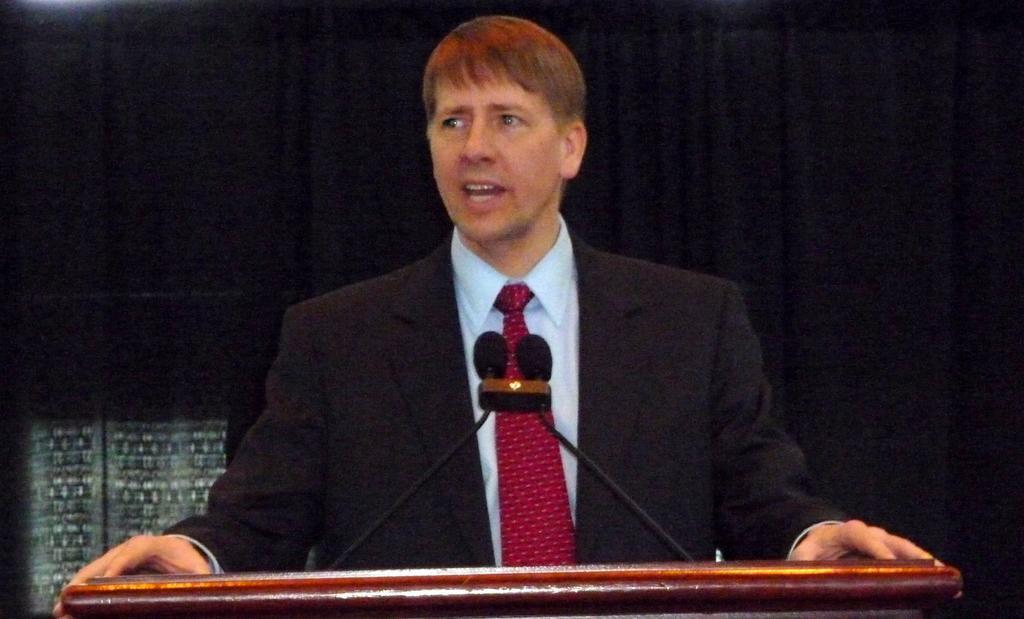In one or two sentences, can you explain what this image depicts? In this image I can see the person wearing the blazer, shirt and the tie. There is a podium in-front of these people. On the podium I can see the mics. And there is a black background. 